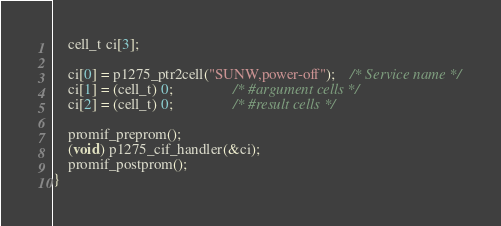Convert code to text. <code><loc_0><loc_0><loc_500><loc_500><_C_>	cell_t ci[3];

	ci[0] = p1275_ptr2cell("SUNW,power-off");	/* Service name */
	ci[1] = (cell_t) 0;				/* #argument cells */
	ci[2] = (cell_t) 0;				/* #result cells */

	promif_preprom();
	(void) p1275_cif_handler(&ci);
	promif_postprom();
}
</code> 